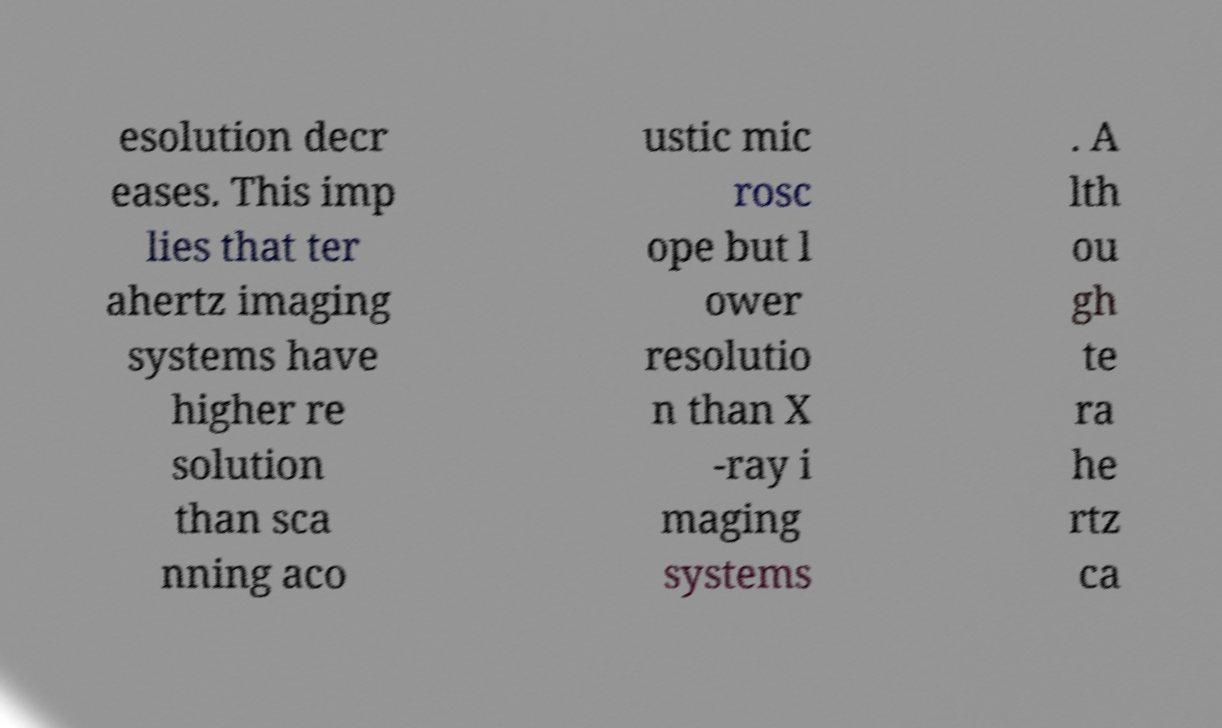Please read and relay the text visible in this image. What does it say? esolution decr eases. This imp lies that ter ahertz imaging systems have higher re solution than sca nning aco ustic mic rosc ope but l ower resolutio n than X -ray i maging systems . A lth ou gh te ra he rtz ca 